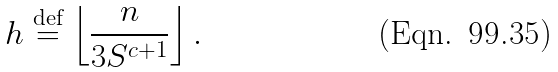<formula> <loc_0><loc_0><loc_500><loc_500>h \stackrel { \text {def} } { = } \left \lfloor \frac { n } { 3 S ^ { c + 1 } } \right \rfloor .</formula> 